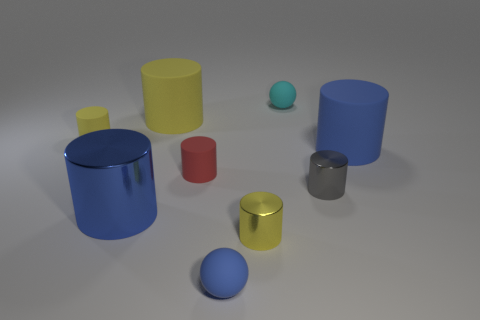How does the lighting affect the appearance of the objects? The lighting creates soft shadows and subtle reflections on the objects, emphasizing their shapes and giving the scene a three-dimensional quality. It also enhances the metallic sheen of the yellow and gray objects. 